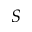Convert formula to latex. <formula><loc_0><loc_0><loc_500><loc_500>S</formula> 